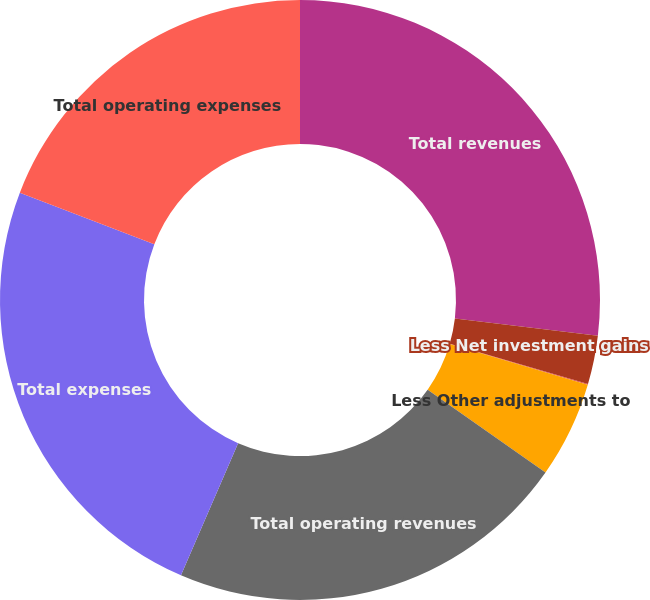<chart> <loc_0><loc_0><loc_500><loc_500><pie_chart><fcel>Total revenues<fcel>Less Net investment gains<fcel>Less Net derivative gains<fcel>Less Other adjustments to<fcel>Total operating revenues<fcel>Total expenses<fcel>Total operating expenses<nl><fcel>26.9%<fcel>2.62%<fcel>0.04%<fcel>5.19%<fcel>21.75%<fcel>24.33%<fcel>19.18%<nl></chart> 